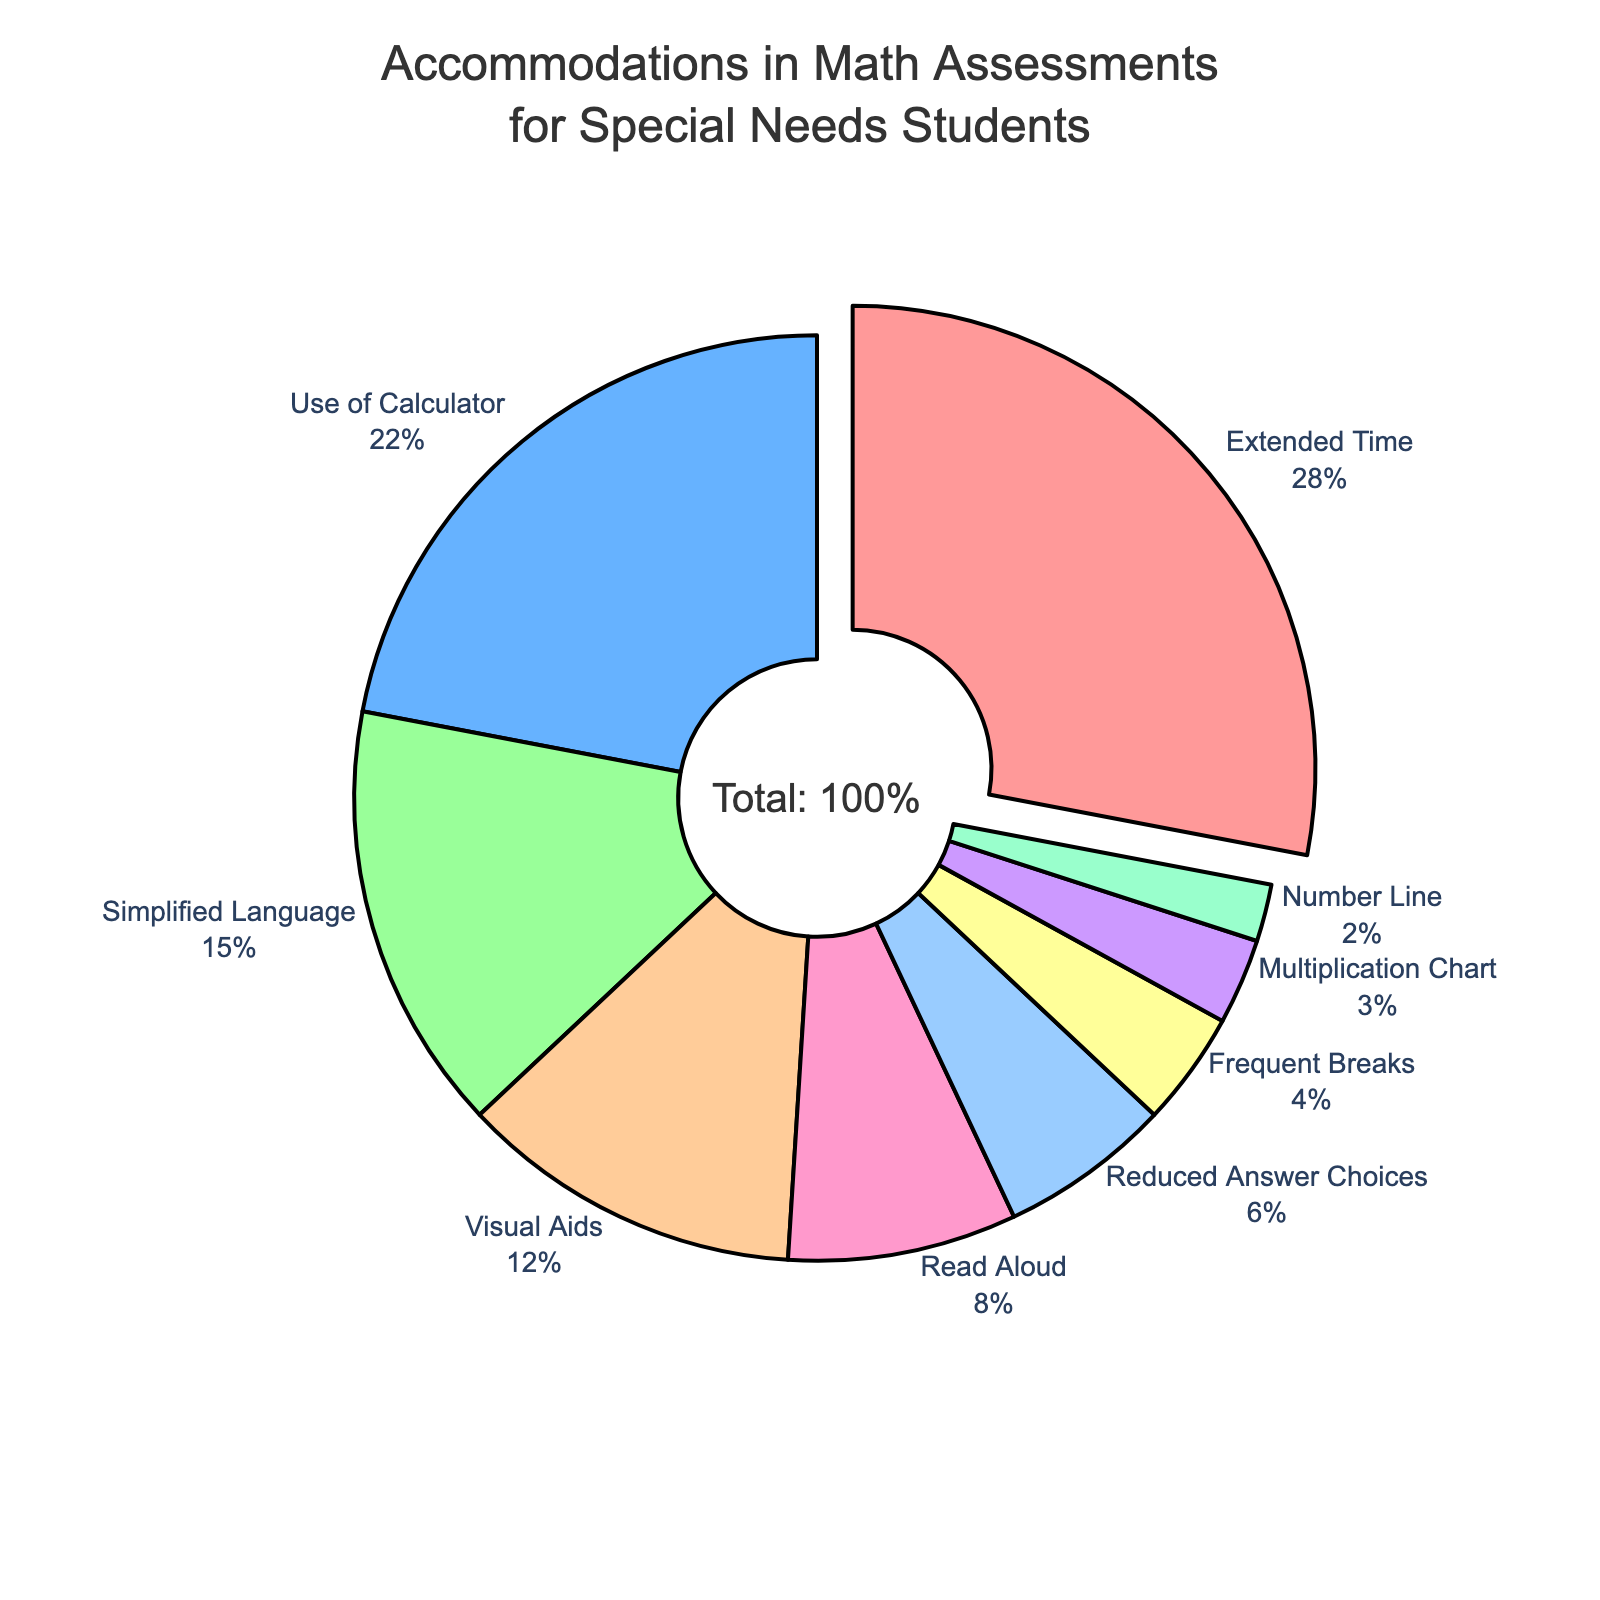What proportion of accommodations in math assessments for special needs students is accounted for by the top two accommodations? The top two accommodations are Extended Time (28%) and Use of Calculator (22%). Summing these percentages gives 28% + 22% = 50%.
Answer: 50% Which accommodation is used the least in math assessments for special needs students, and what is its percentage? The accommodation with the smallest slice on the pie chart is Number Line, with a percentage of 2%.
Answer: Number Line, 2% How much more often is Extended Time used compared to Read Aloud? The percentage for Extended Time is 28%, and for Read Aloud, it is 8%. The difference is 28% - 8% = 20%.
Answer: 20% Which accommodation has a larger proportion, Visual Aids or Simplified Language, and by how much? Visual Aids has a proportion of 12%, and Simplified Language has a proportion of 15%. The difference is 15% - 12% = 3%. Simplified Language has the larger proportion.
Answer: Simplified Language, 3% What is the combined percentage of accommodations that individually account for 6% or less? The accommodations with 6% or less are Reduced Answer Choices (6%), Frequent Breaks (4%), Multiplication Chart (3%), and Number Line (2%). Adding these together: 6% + 4% + 3% + 2% = 15%.
Answer: 15% 